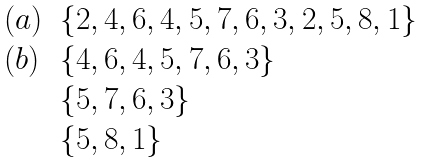<formula> <loc_0><loc_0><loc_500><loc_500>\begin{array} { l l } ( a ) & \{ 2 , 4 , 6 , 4 , 5 , 7 , 6 , 3 , 2 , 5 , 8 , 1 \} \\ ( b ) & \{ 4 , 6 , 4 , 5 , 7 , 6 , 3 \} \\ & \{ 5 , 7 , 6 , 3 \} \\ & \{ 5 , 8 , 1 \} \\ \end{array}</formula> 